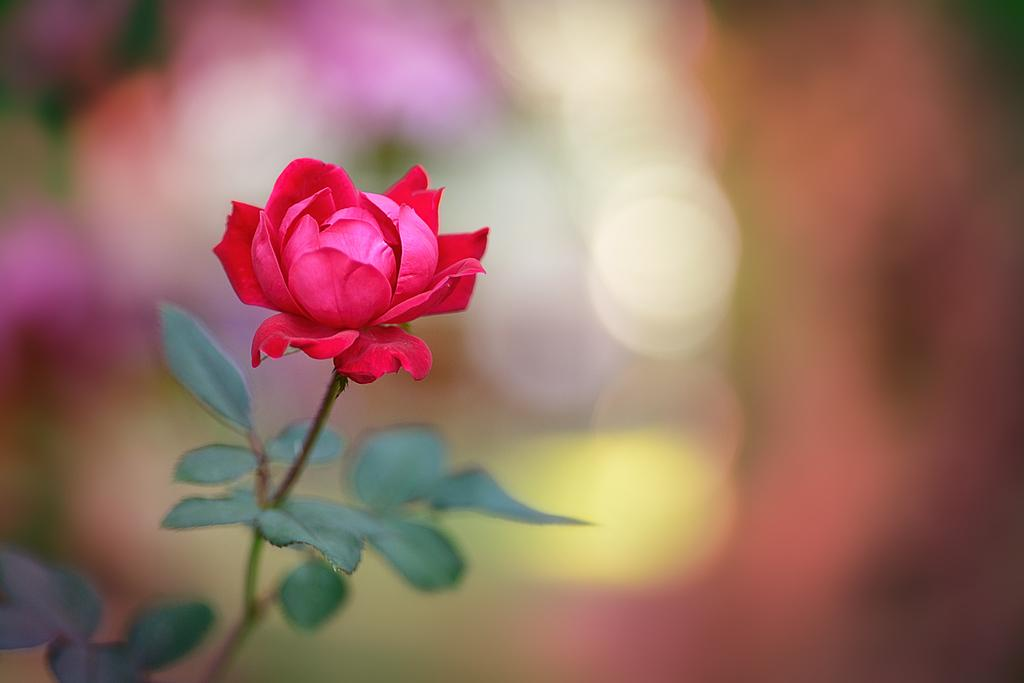What type of plant is in the picture? There is a rose plant in the picture. What part of the plant is visible in the picture? There is a flower in the picture. Can you describe the background of the image? The background of the image is blurry. How many silk threads are woven into the tooth in the image? There is no tooth or silk threads present in the image; it features a rose plant with a flower. 